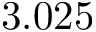<formula> <loc_0><loc_0><loc_500><loc_500>3 . 0 2 5</formula> 